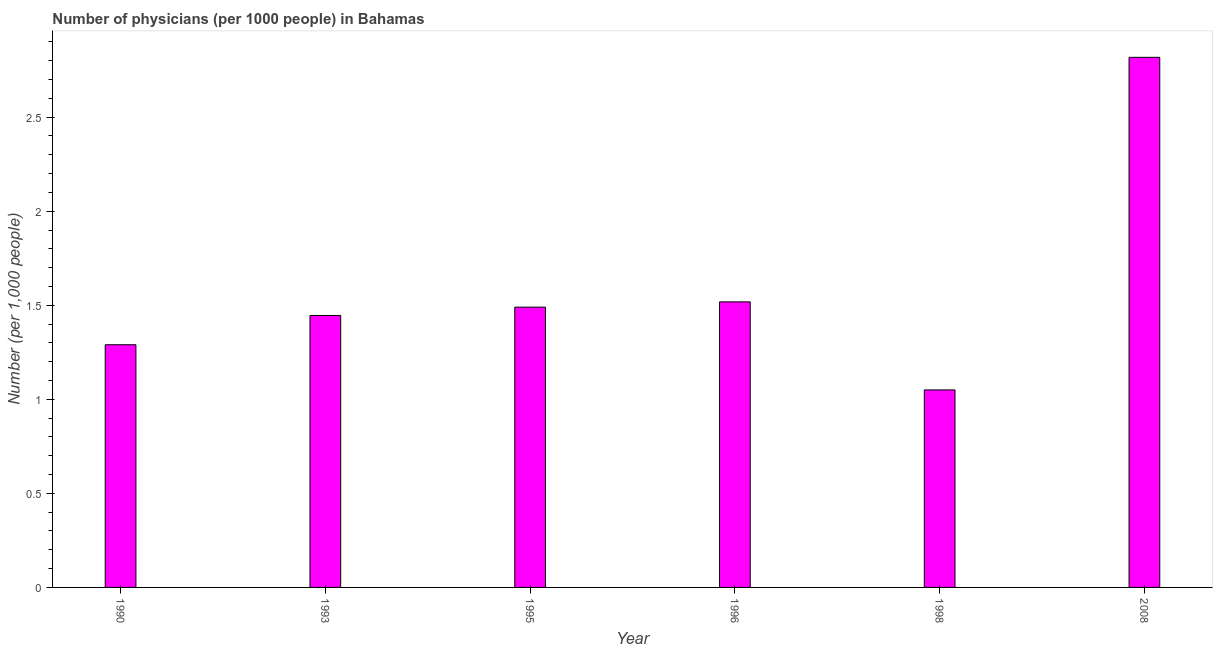What is the title of the graph?
Ensure brevity in your answer.  Number of physicians (per 1000 people) in Bahamas. What is the label or title of the Y-axis?
Make the answer very short. Number (per 1,0 people). What is the number of physicians in 1995?
Provide a short and direct response. 1.49. Across all years, what is the maximum number of physicians?
Your answer should be compact. 2.82. In which year was the number of physicians maximum?
Make the answer very short. 2008. In which year was the number of physicians minimum?
Offer a very short reply. 1998. What is the sum of the number of physicians?
Your response must be concise. 9.61. What is the difference between the number of physicians in 1993 and 1996?
Offer a terse response. -0.07. What is the average number of physicians per year?
Offer a terse response. 1.6. What is the median number of physicians?
Your response must be concise. 1.47. In how many years, is the number of physicians greater than 2.8 ?
Ensure brevity in your answer.  1. Do a majority of the years between 1990 and 1995 (inclusive) have number of physicians greater than 0.1 ?
Offer a very short reply. Yes. Is the sum of the number of physicians in 1995 and 2008 greater than the maximum number of physicians across all years?
Ensure brevity in your answer.  Yes. What is the difference between the highest and the lowest number of physicians?
Your answer should be compact. 1.77. How many bars are there?
Make the answer very short. 6. Are all the bars in the graph horizontal?
Give a very brief answer. No. What is the difference between two consecutive major ticks on the Y-axis?
Provide a succinct answer. 0.5. What is the Number (per 1,000 people) in 1990?
Keep it short and to the point. 1.29. What is the Number (per 1,000 people) of 1993?
Keep it short and to the point. 1.45. What is the Number (per 1,000 people) in 1995?
Your response must be concise. 1.49. What is the Number (per 1,000 people) of 1996?
Keep it short and to the point. 1.52. What is the Number (per 1,000 people) of 1998?
Provide a succinct answer. 1.05. What is the Number (per 1,000 people) in 2008?
Give a very brief answer. 2.82. What is the difference between the Number (per 1,000 people) in 1990 and 1993?
Give a very brief answer. -0.16. What is the difference between the Number (per 1,000 people) in 1990 and 1995?
Give a very brief answer. -0.2. What is the difference between the Number (per 1,000 people) in 1990 and 1996?
Provide a succinct answer. -0.23. What is the difference between the Number (per 1,000 people) in 1990 and 1998?
Give a very brief answer. 0.24. What is the difference between the Number (per 1,000 people) in 1990 and 2008?
Your answer should be compact. -1.53. What is the difference between the Number (per 1,000 people) in 1993 and 1995?
Your answer should be compact. -0.04. What is the difference between the Number (per 1,000 people) in 1993 and 1996?
Your answer should be very brief. -0.07. What is the difference between the Number (per 1,000 people) in 1993 and 1998?
Offer a terse response. 0.4. What is the difference between the Number (per 1,000 people) in 1993 and 2008?
Offer a very short reply. -1.37. What is the difference between the Number (per 1,000 people) in 1995 and 1996?
Give a very brief answer. -0.03. What is the difference between the Number (per 1,000 people) in 1995 and 1998?
Your answer should be very brief. 0.44. What is the difference between the Number (per 1,000 people) in 1995 and 2008?
Provide a succinct answer. -1.33. What is the difference between the Number (per 1,000 people) in 1996 and 1998?
Provide a succinct answer. 0.47. What is the difference between the Number (per 1,000 people) in 1998 and 2008?
Offer a very short reply. -1.77. What is the ratio of the Number (per 1,000 people) in 1990 to that in 1993?
Your response must be concise. 0.89. What is the ratio of the Number (per 1,000 people) in 1990 to that in 1995?
Keep it short and to the point. 0.87. What is the ratio of the Number (per 1,000 people) in 1990 to that in 1996?
Your response must be concise. 0.85. What is the ratio of the Number (per 1,000 people) in 1990 to that in 1998?
Your response must be concise. 1.23. What is the ratio of the Number (per 1,000 people) in 1990 to that in 2008?
Provide a succinct answer. 0.46. What is the ratio of the Number (per 1,000 people) in 1993 to that in 1995?
Ensure brevity in your answer.  0.97. What is the ratio of the Number (per 1,000 people) in 1993 to that in 1998?
Your answer should be compact. 1.38. What is the ratio of the Number (per 1,000 people) in 1993 to that in 2008?
Your response must be concise. 0.51. What is the ratio of the Number (per 1,000 people) in 1995 to that in 1998?
Provide a short and direct response. 1.42. What is the ratio of the Number (per 1,000 people) in 1995 to that in 2008?
Your answer should be compact. 0.53. What is the ratio of the Number (per 1,000 people) in 1996 to that in 1998?
Your answer should be compact. 1.45. What is the ratio of the Number (per 1,000 people) in 1996 to that in 2008?
Your response must be concise. 0.54. What is the ratio of the Number (per 1,000 people) in 1998 to that in 2008?
Provide a short and direct response. 0.37. 